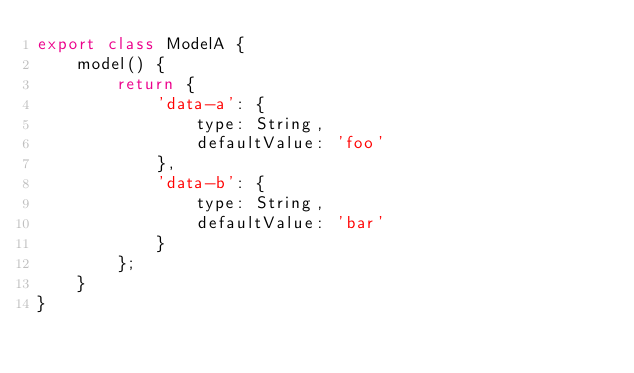Convert code to text. <code><loc_0><loc_0><loc_500><loc_500><_JavaScript_>export class ModelA {
    model() {
        return {
            'data-a': {
                type: String,
                defaultValue: 'foo'
            },
            'data-b': {
                type: String,
                defaultValue: 'bar'
            }
        };
    }
}
</code> 